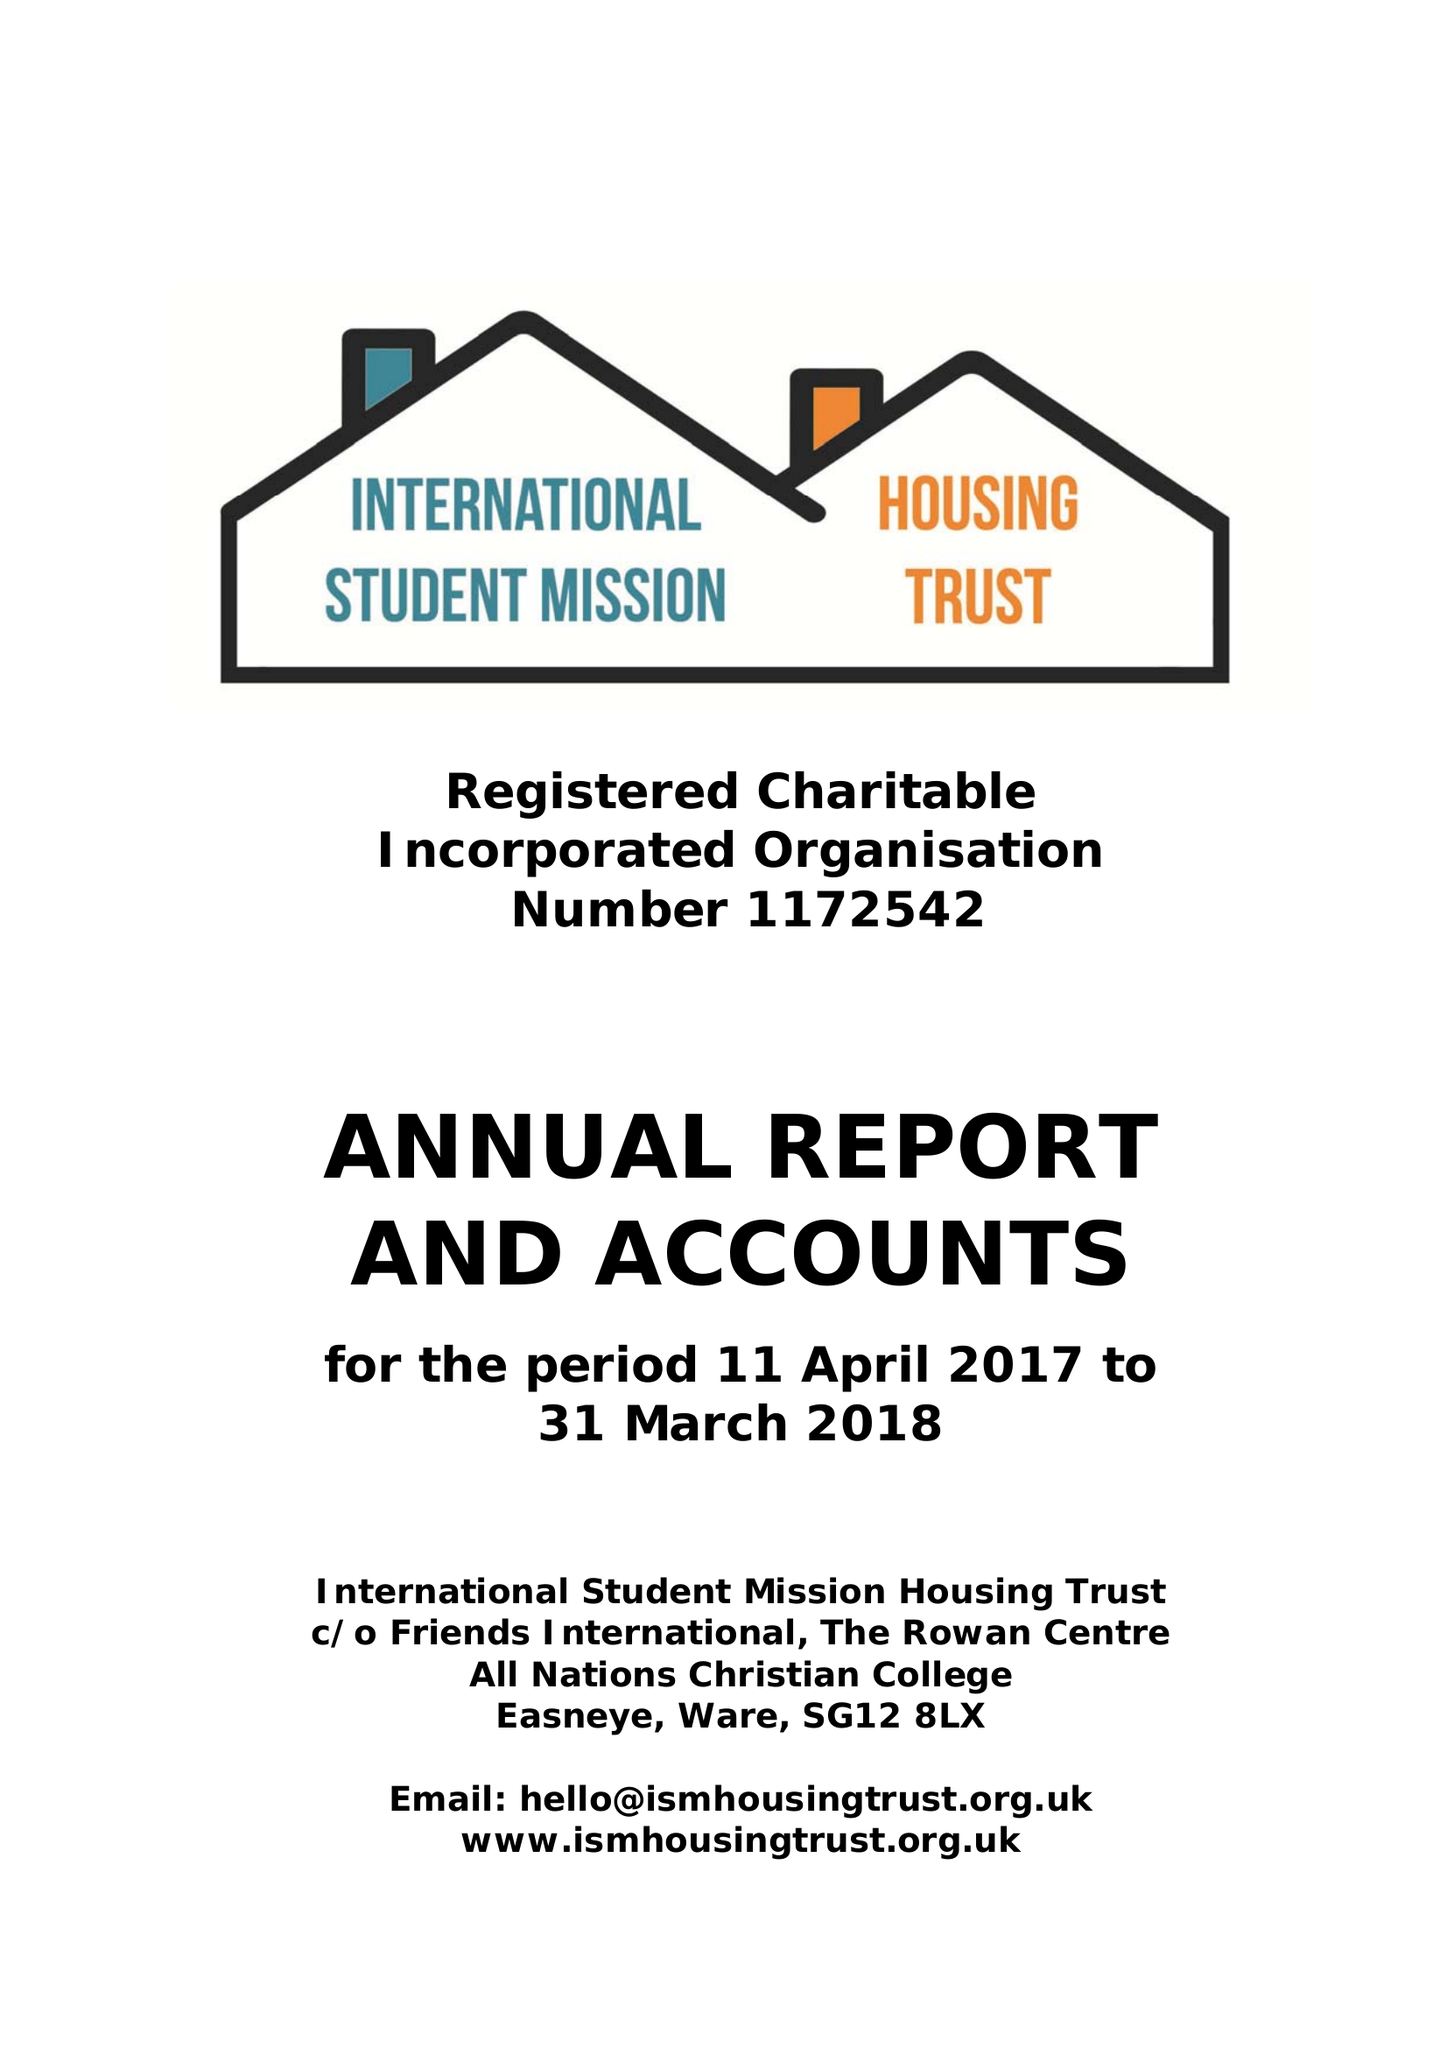What is the value for the charity_name?
Answer the question using a single word or phrase. International Student Mission Housing Trust 